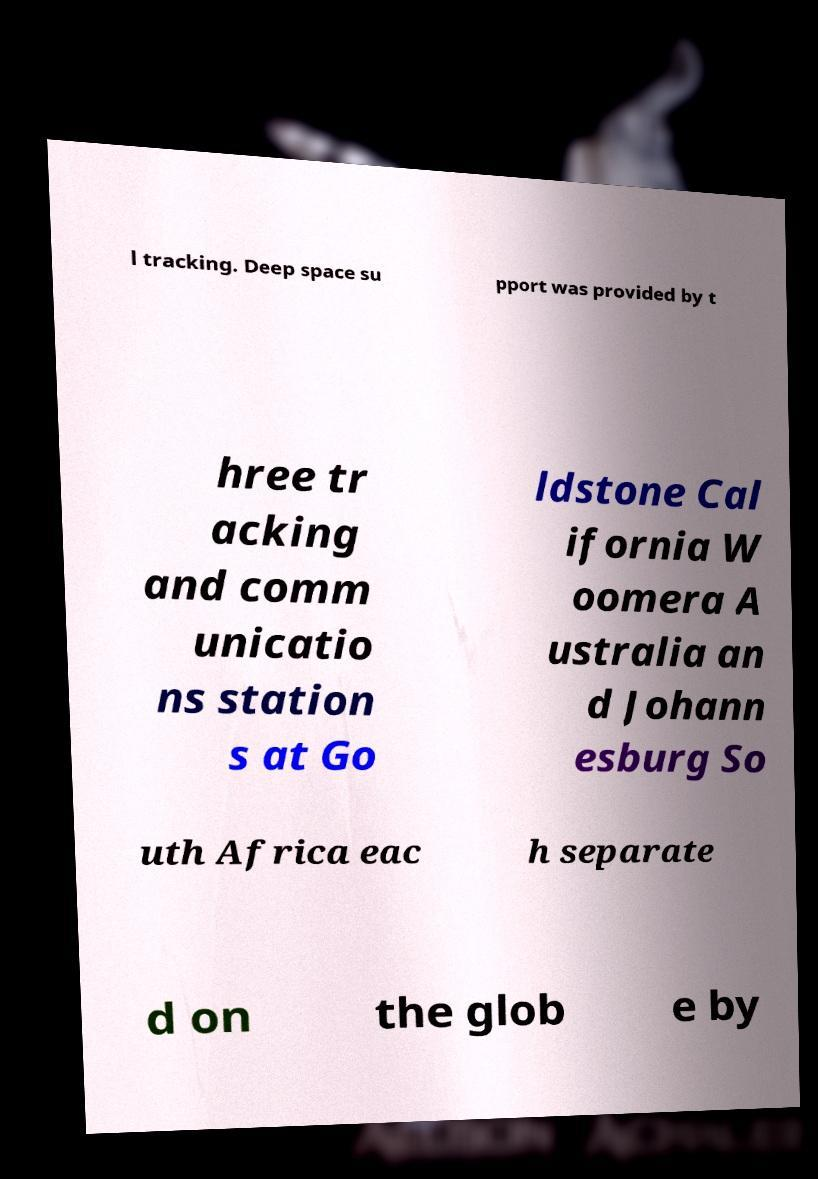For documentation purposes, I need the text within this image transcribed. Could you provide that? l tracking. Deep space su pport was provided by t hree tr acking and comm unicatio ns station s at Go ldstone Cal ifornia W oomera A ustralia an d Johann esburg So uth Africa eac h separate d on the glob e by 